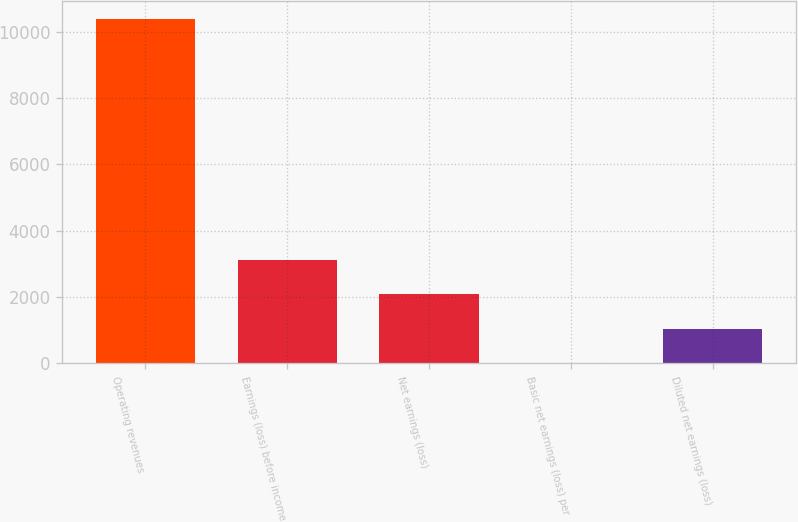Convert chart to OTSL. <chart><loc_0><loc_0><loc_500><loc_500><bar_chart><fcel>Operating revenues<fcel>Earnings (loss) before income<fcel>Net earnings (loss)<fcel>Basic net earnings (loss) per<fcel>Diluted net earnings (loss)<nl><fcel>10397<fcel>3119.13<fcel>2079.44<fcel>0.06<fcel>1039.75<nl></chart> 